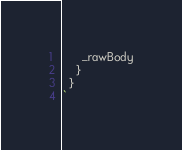Convert code to text. <code><loc_0><loc_0><loc_500><loc_500><_JavaScript_>      _rawBody
    }
  }
`
</code> 